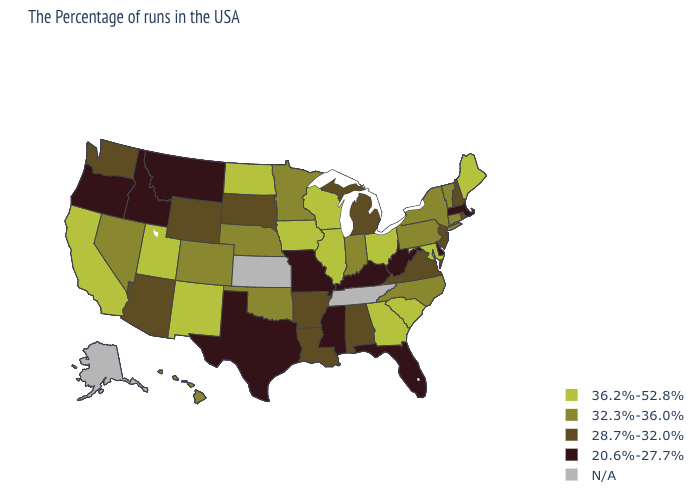How many symbols are there in the legend?
Be succinct. 5. What is the highest value in the West ?
Concise answer only. 36.2%-52.8%. Among the states that border New Hampshire , does Massachusetts have the highest value?
Keep it brief. No. What is the highest value in the USA?
Concise answer only. 36.2%-52.8%. Among the states that border Oregon , does Washington have the lowest value?
Give a very brief answer. No. Name the states that have a value in the range 28.7%-32.0%?
Concise answer only. Rhode Island, New Hampshire, New Jersey, Virginia, Michigan, Alabama, Louisiana, Arkansas, South Dakota, Wyoming, Arizona, Washington. Among the states that border North Carolina , does Virginia have the lowest value?
Keep it brief. Yes. Does Alabama have the lowest value in the South?
Write a very short answer. No. Among the states that border Washington , which have the highest value?
Concise answer only. Idaho, Oregon. What is the value of Hawaii?
Quick response, please. 32.3%-36.0%. What is the value of Massachusetts?
Concise answer only. 20.6%-27.7%. Name the states that have a value in the range 32.3%-36.0%?
Give a very brief answer. Vermont, Connecticut, New York, Pennsylvania, North Carolina, Indiana, Minnesota, Nebraska, Oklahoma, Colorado, Nevada, Hawaii. What is the highest value in states that border Mississippi?
Short answer required. 28.7%-32.0%. What is the value of California?
Quick response, please. 36.2%-52.8%. 